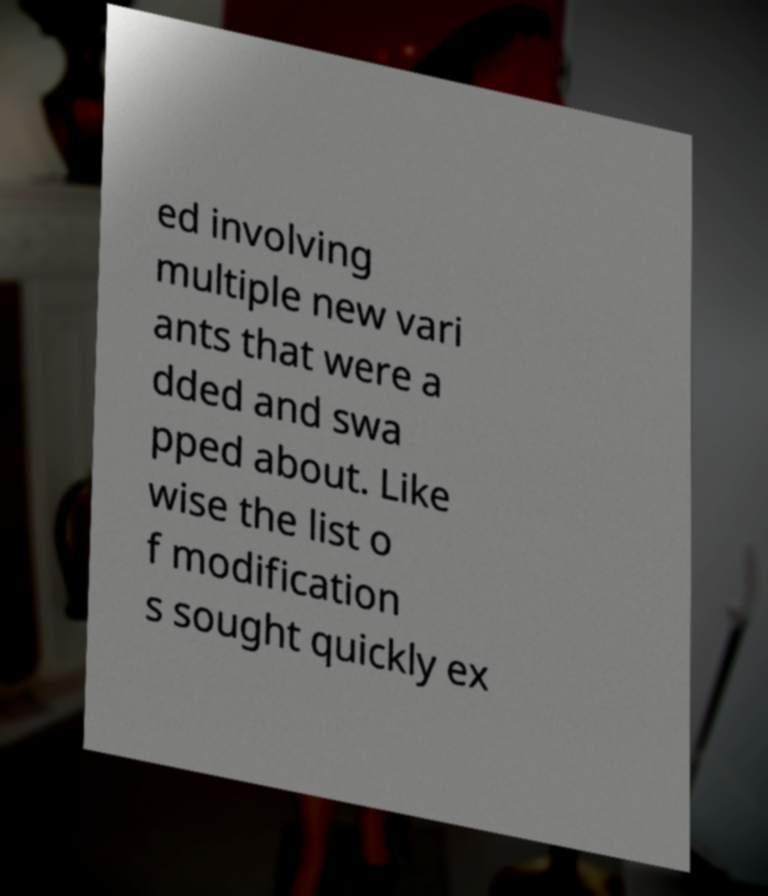What messages or text are displayed in this image? I need them in a readable, typed format. ed involving multiple new vari ants that were a dded and swa pped about. Like wise the list o f modification s sought quickly ex 